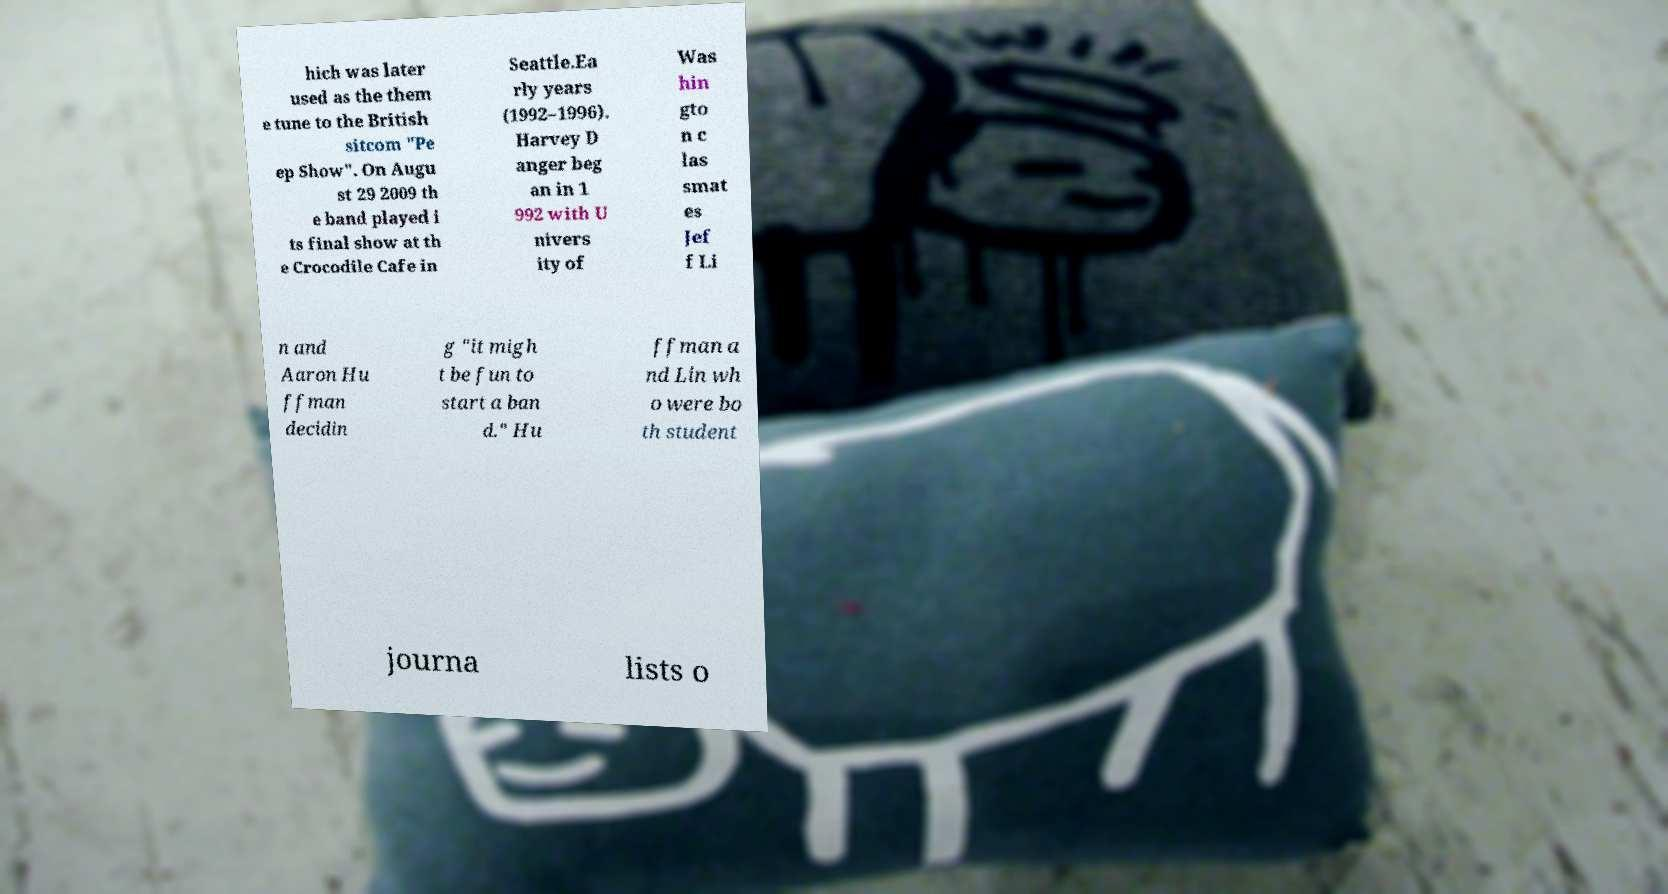Can you read and provide the text displayed in the image?This photo seems to have some interesting text. Can you extract and type it out for me? hich was later used as the them e tune to the British sitcom "Pe ep Show". On Augu st 29 2009 th e band played i ts final show at th e Crocodile Cafe in Seattle.Ea rly years (1992–1996). Harvey D anger beg an in 1 992 with U nivers ity of Was hin gto n c las smat es Jef f Li n and Aaron Hu ffman decidin g "it migh t be fun to start a ban d." Hu ffman a nd Lin wh o were bo th student journa lists o 